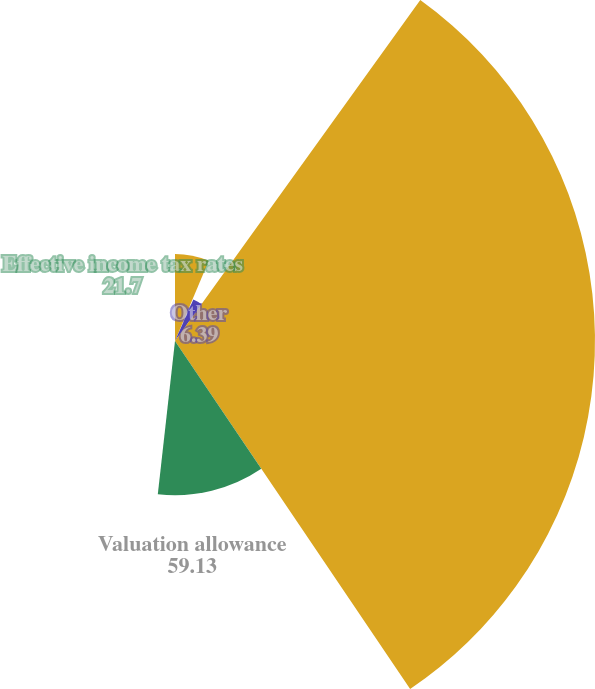Convert chart to OTSL. <chart><loc_0><loc_0><loc_500><loc_500><pie_chart><fcel>State income tax net of<fcel>Meals and entertainment<fcel>Other<fcel>Valuation allowance<fcel>Effective income tax rates<nl><fcel>12.25%<fcel>0.53%<fcel>6.39%<fcel>59.13%<fcel>21.7%<nl></chart> 